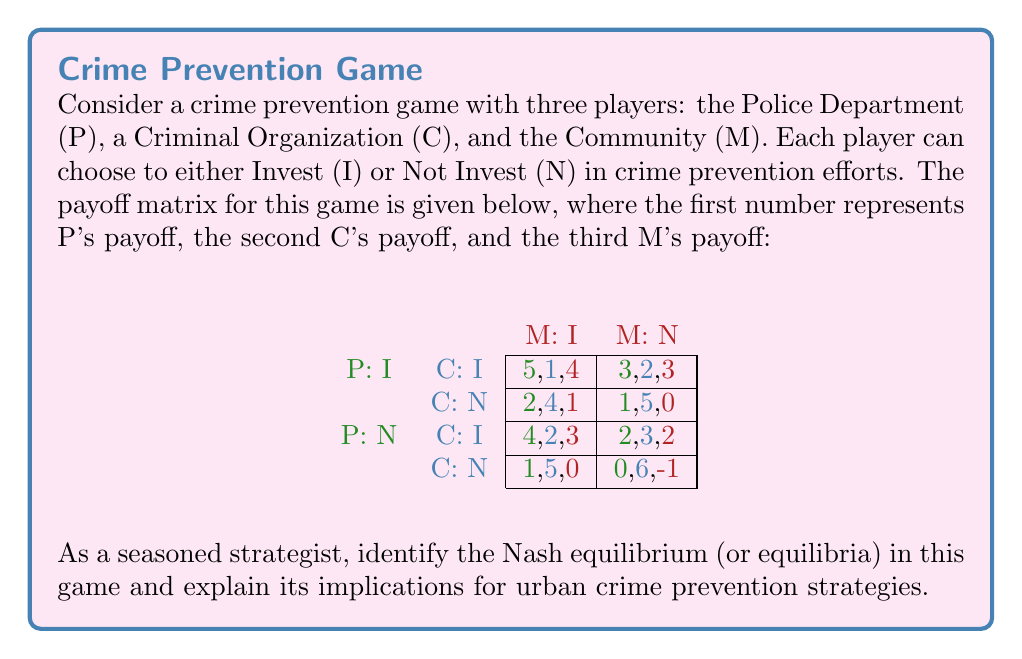Solve this math problem. To find the Nash equilibrium, we need to analyze each player's best response to the other players' strategies. Let's approach this step-by-step:

1) First, let's consider each player's best response for every combination of the other players' strategies:

   For Police (P):
   - If C:I, M:I → P:I (5 > 4)
   - If C:I, M:N → P:I (3 > 2)
   - If C:N, M:I → P:I (2 > 1)
   - If C:N, M:N → P:I (1 > 0)

   For Criminal Organization (C):
   - If P:I, M:I → C:N (4 > 1)
   - If P:I, M:N → C:N (5 > 2)
   - If P:N, M:I → C:N (5 > 2)
   - If P:N, M:N → C:N (6 > 3)

   For Community (M):
   - If P:I, C:I → M:I (4 > 3)
   - If P:I, C:N → M:I (1 > 0)
   - If P:N, C:I → M:I (3 > 2)
   - If P:N, C:N → M:I (0 > -1)

2) From this analysis, we can see that:
   - P's dominant strategy is to Invest (I)
   - C's dominant strategy is Not to Invest (N)
   - M's dominant strategy is to Invest (I)

3) Therefore, the Nash equilibrium is (P:I, C:N, M:I) with payoffs (2, 4, 1).

4) Implications for urban crime prevention strategies:

   a) The Police Department will always invest in crime prevention, regardless of what others do. This suggests that consistent law enforcement effort is crucial.

   b) The Criminal Organization will always choose not to invest in criminal activities when faced with active police and community involvement. This indicates that a strong preventive presence can deter organized crime.

   c) The Community will always choose to invest in crime prevention, highlighting the importance of community engagement in crime reduction efforts.

   d) The equilibrium payoffs (2, 4, 1) show that while all parties benefit from their strategies, the Criminal Organization gains the most. This counterintuitive result suggests that even when crime is reduced, criminal organizations may find ways to adapt and profit, possibly through more sophisticated or less detectable crimes.

   e) The relatively low payoff for the Community (1) in the equilibrium state suggests that while community involvement is crucial, it may come at a cost (e.g., time, resources, potential risk). This highlights the need for policies that support and incentivize community participation in crime prevention.
Answer: Nash equilibrium: (P:I, C:N, M:I) with payoffs (2, 4, 1) 